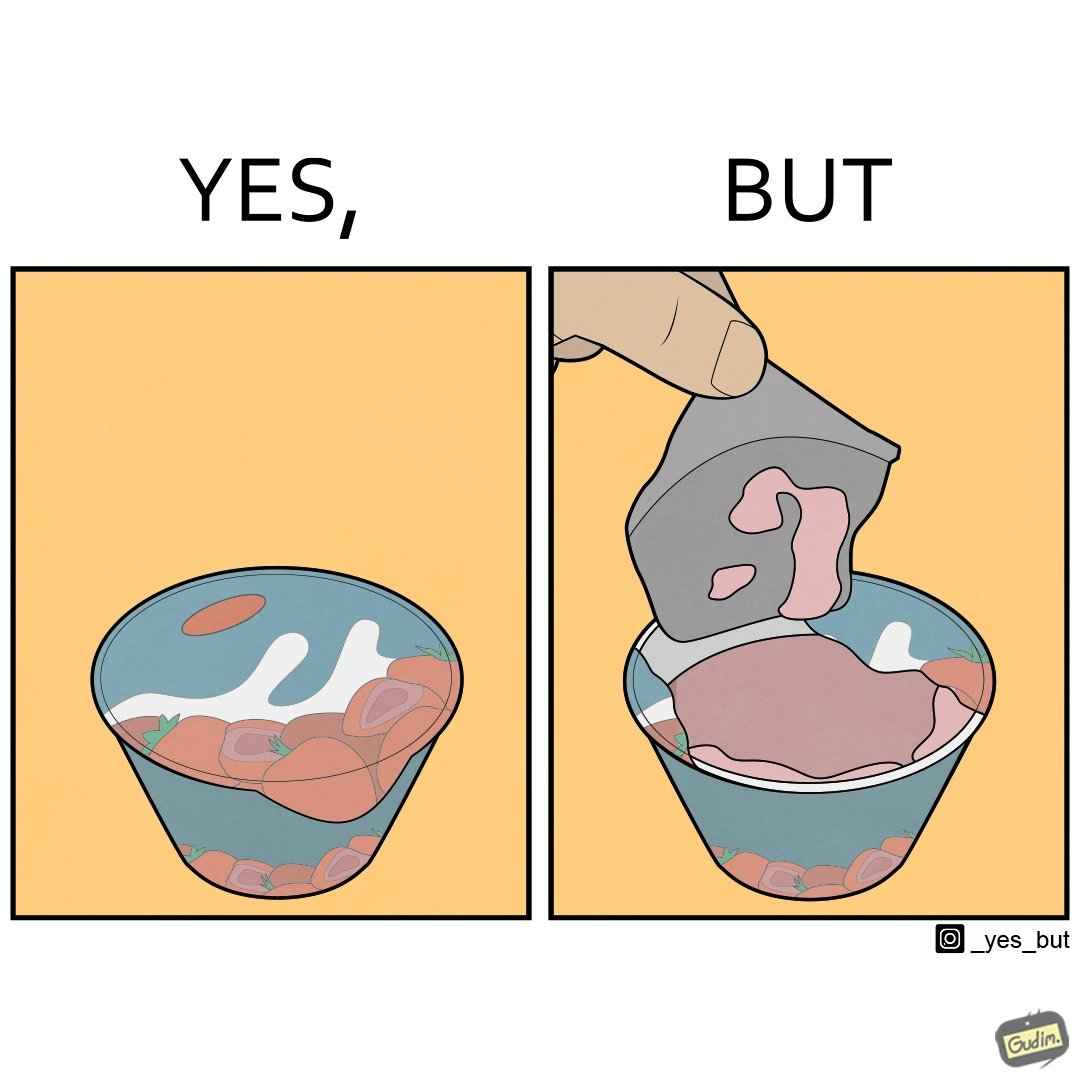Provide a description of this image. The images are funny since it shows how the food packaging sets unreal expectations for the food inside with its graphics. The user gets to see the rather dull food once he opens the package and it is amusing to see how different the actual product is from the images 